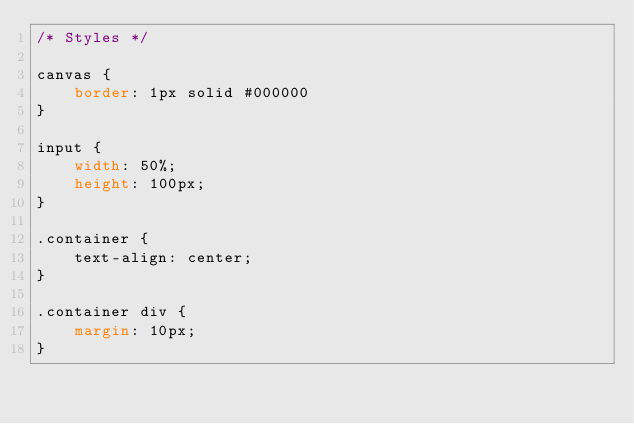Convert code to text. <code><loc_0><loc_0><loc_500><loc_500><_CSS_>/* Styles */

canvas {
    border: 1px solid #000000
}

input {
    width: 50%;
    height: 100px;
}

.container {
    text-align: center;
}

.container div {
    margin: 10px;
}</code> 